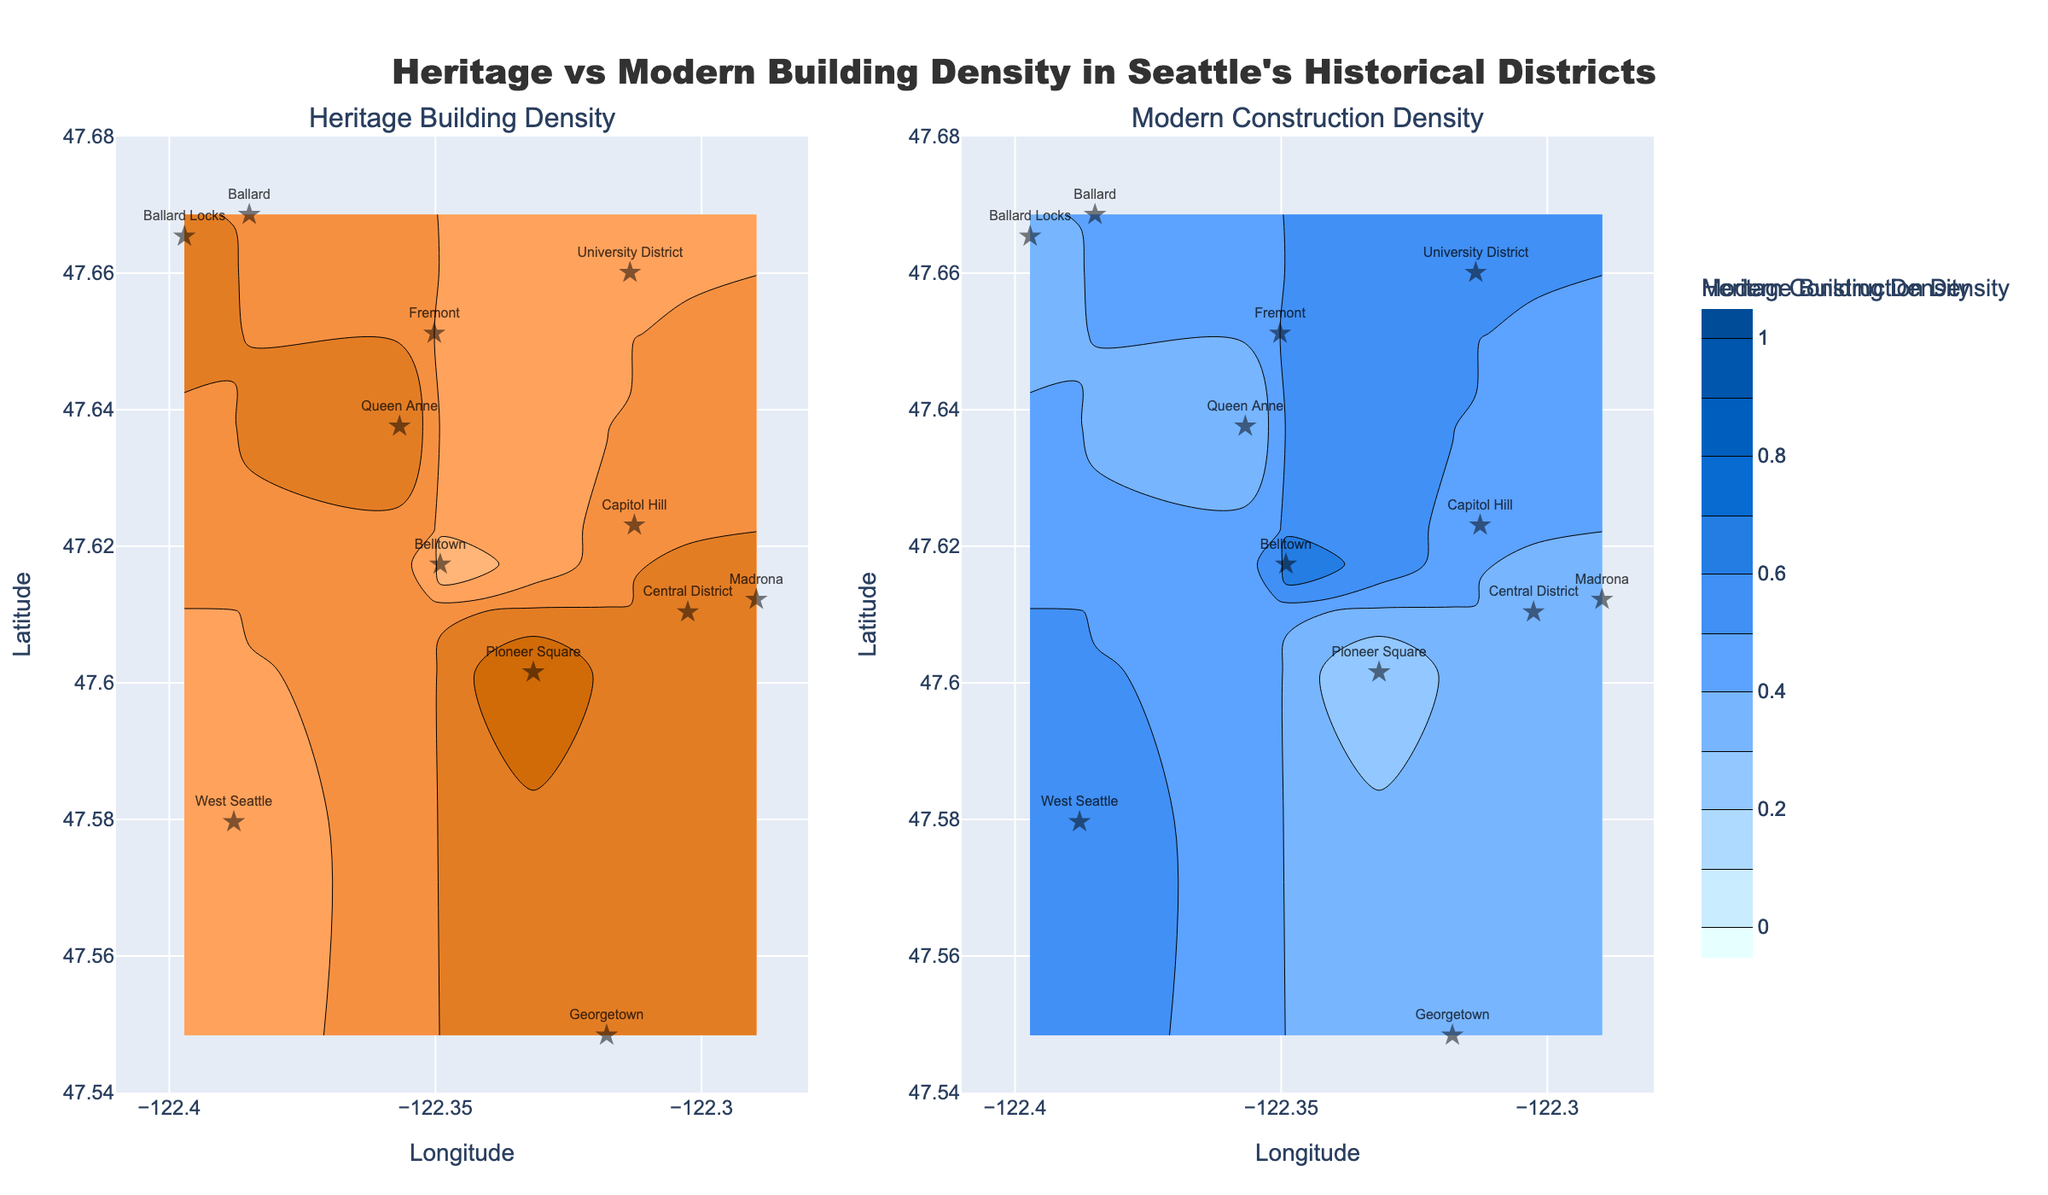what are the titles of the two contour plots? The titles of the two contour plots are displayed above each plot. The first plot's title is "Heritage Building Density," and the second plot's title is "Modern Construction Density."
Answer: Heritage Building Density, Modern Construction Density how many historical districts are shown in the plots? To find the number of historical districts, you can count the number of unique district names labeled on the plots. There are twelve district names listed: Pioneer Square, Capitol Hill, Ballard, Queen Anne, University District, Belltown, Fremont, Georgetown, Madrona, West Seattle, Central District, and Ballard Locks.
Answer: 12 which district has the highest density of heritage buildings? By examining the "Heritage Building Density" plot, the district with the highest density value (0.8) is Pioneer Square, indicated by its density reading and the color gradient.
Answer: Pioneer Square compare the building density in Capitol Hill and Belltown for both heritage and modern constructions. In the "Heritage Building Density" plot, Capitol Hill has a density of 0.6, while Belltown has a density of 0.3. In the "Modern Construction Density" plot, Capitol Hill has a density of 0.4, and Belltown has a density of 0.7. So, Capitol Hill has a higher heritage building density but lower modern construction density compared to Belltown.
Answer: Capitol Hill: Heritage 0.6, Modern 0.4; Belltown: Heritage 0.3, Modern 0.7 what is the combined average density of heritage buildings in Capitol Hill and Queen Anne? The combined average density is calculated by summing the heritage densities of Capitol Hill (0.6) and Queen Anne (0.7) and dividing by 2. \( (0.6 + 0.7) / 2 = 0.65 \)
Answer: 0.65 identify the district with equal density of heritage and modern constructions. On both contour plots, the districts with equal density for heritage and modern constructions are represented by the same color gradient level. Ballard and Fremont both have equal densities of 0.5 each for heritage and modern constructions.
Answer: Ballard, Fremont which district has the lowest heritage building density and what is its modern construction density? By examining the "Heritage Building Density" plot, Belltown has the lowest heritage density of 0.3. According to the "Modern Construction Density" plot, Belltown's modern construction density is 0.7.
Answer: Belltown, 0.7 what visual elements are used to differentiate between the heritage and modern construction density plots? Two different color scales are used: warm colors (light yellow to dark brown) for "Heritage Building Density" and cool colors (light cyan to dark blue) for "Modern Construction Density." Additionally, each plot is titled differently to indicate the density type.
Answer: colors and titles how do the densities of heritage and modern buildings in Georgetown compare? In the "Heritage Building Density" plot, Georgetown has a density of 0.6, while in the "Modern Construction Density" plot, it has a density of 0.4, indicating that Georgetown has a higher density of heritage buildings compared to modern constructions.
Answer: Heritage 0.6, Modern 0.4 what are the latitude and longitude ranges displayed in both plots? Both plots share the same axes ranges. The longitude ranges from approximately -122.41 to -122.28, and the latitude ranges from approximately 47.54 to 47.68.
Answer: Longitude: -122.41 to -122.28, Latitude: 47.54 to 47.68 